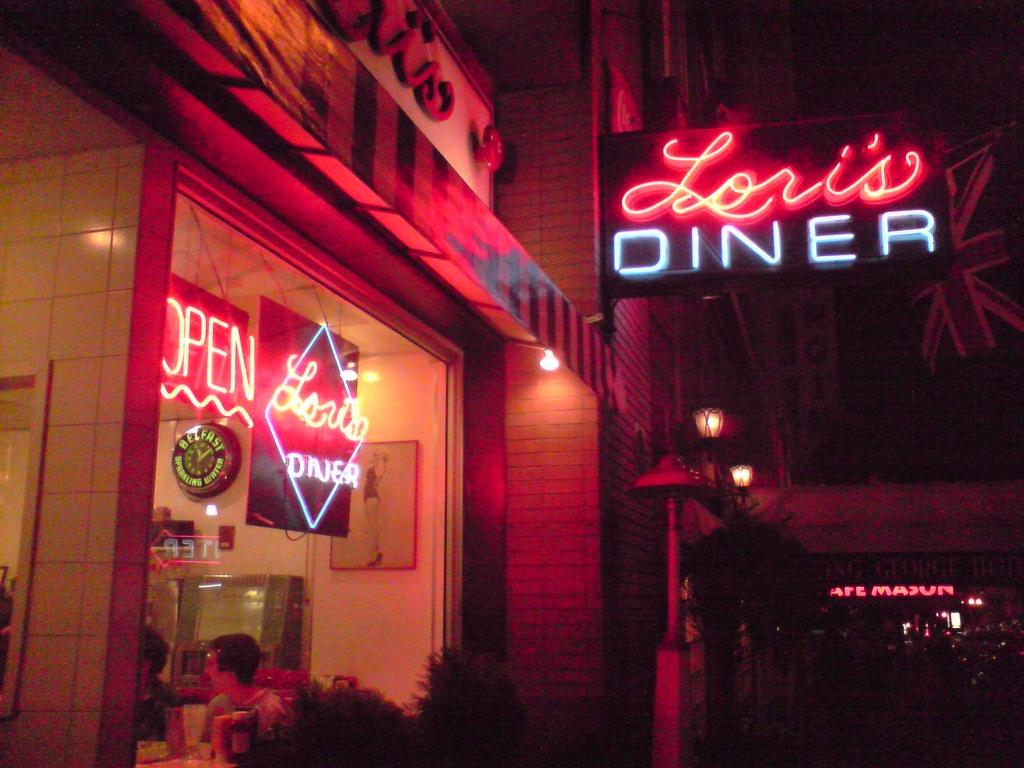<image>
Create a compact narrative representing the image presented. Lori's Diner has a sign in the window declaring it open. 